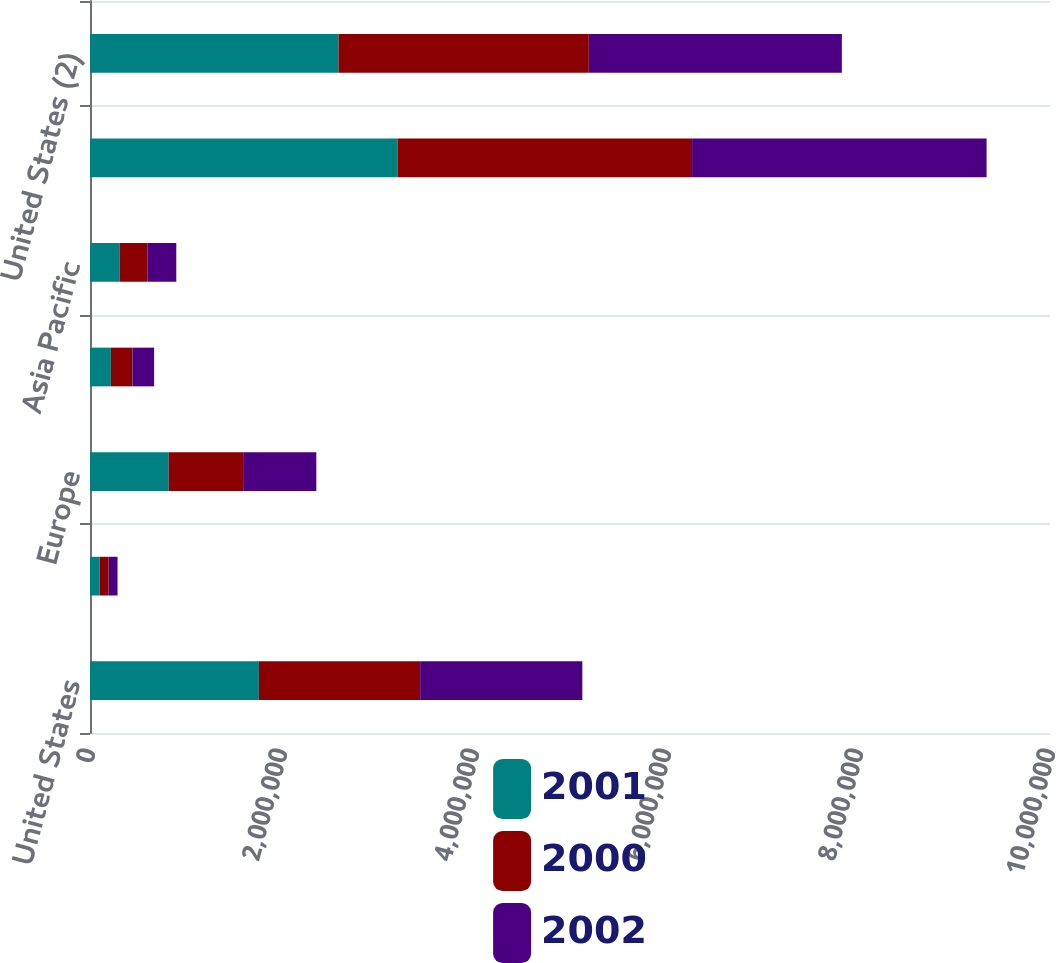Convert chart to OTSL. <chart><loc_0><loc_0><loc_500><loc_500><stacked_bar_chart><ecel><fcel>United States<fcel>Canada<fcel>Europe<fcel>Latin America<fcel>Asia Pacific<fcel>Total<fcel>United States (2)<nl><fcel>2001<fcel>1.75876e+06<fcel>100805<fcel>819531<fcel>217006<fcel>308153<fcel>3.20426e+06<fcel>2.58911e+06<nl><fcel>2000<fcel>1.6802e+06<fcel>93460<fcel>775673<fcel>225573<fcel>292572<fcel>3.06748e+06<fcel>2.60673e+06<nl><fcel>2002<fcel>1.68947e+06<fcel>92559<fcel>762271<fcel>225229<fcel>298188<fcel>3.06771e+06<fcel>2.63593e+06<nl></chart> 